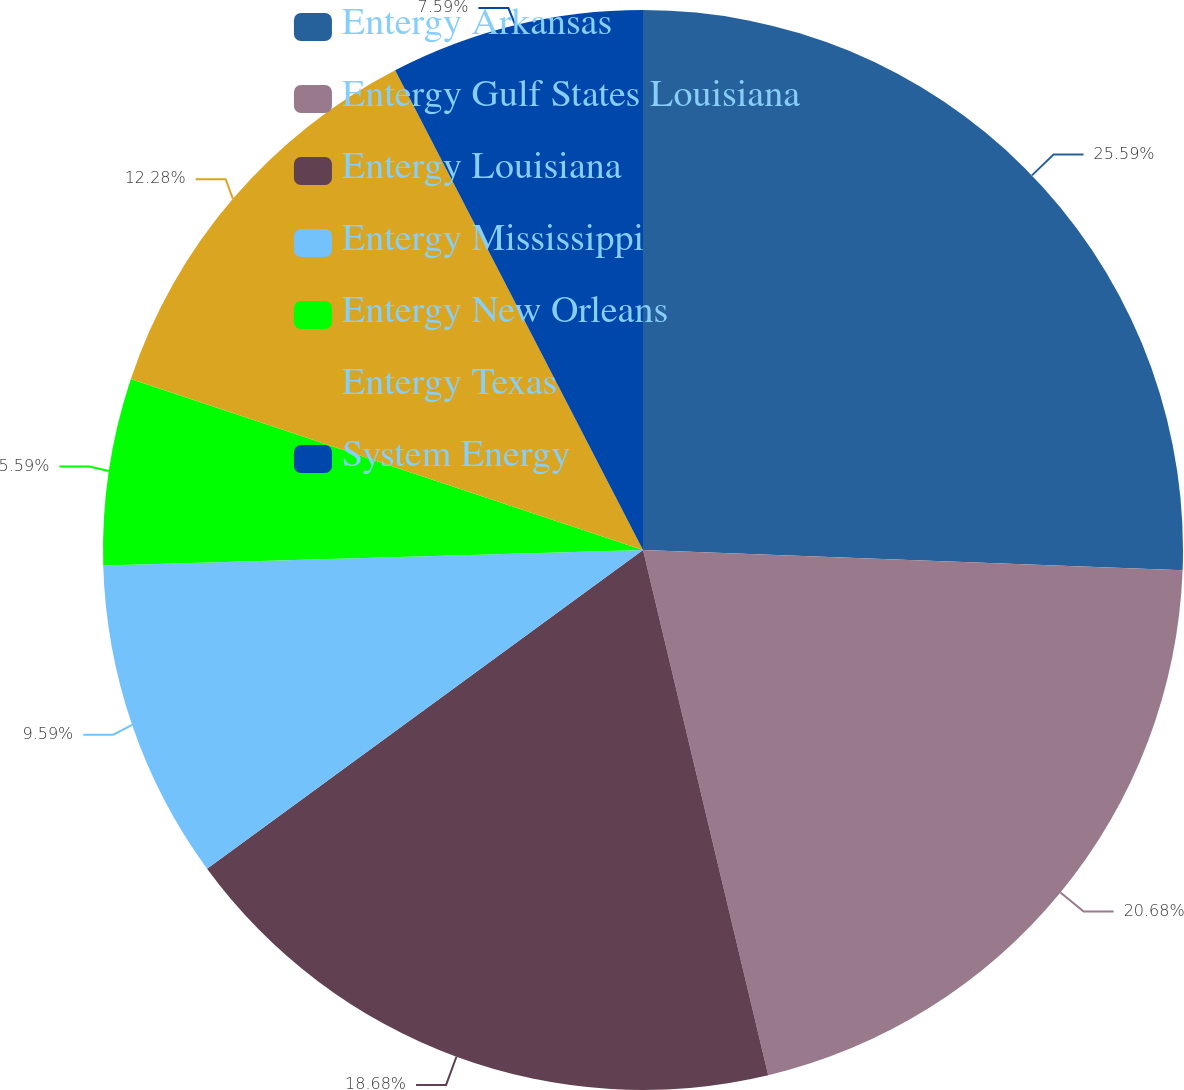<chart> <loc_0><loc_0><loc_500><loc_500><pie_chart><fcel>Entergy Arkansas<fcel>Entergy Gulf States Louisiana<fcel>Entergy Louisiana<fcel>Entergy Mississippi<fcel>Entergy New Orleans<fcel>Entergy Texas<fcel>System Energy<nl><fcel>25.6%<fcel>20.68%<fcel>18.68%<fcel>9.59%<fcel>5.59%<fcel>12.28%<fcel>7.59%<nl></chart> 